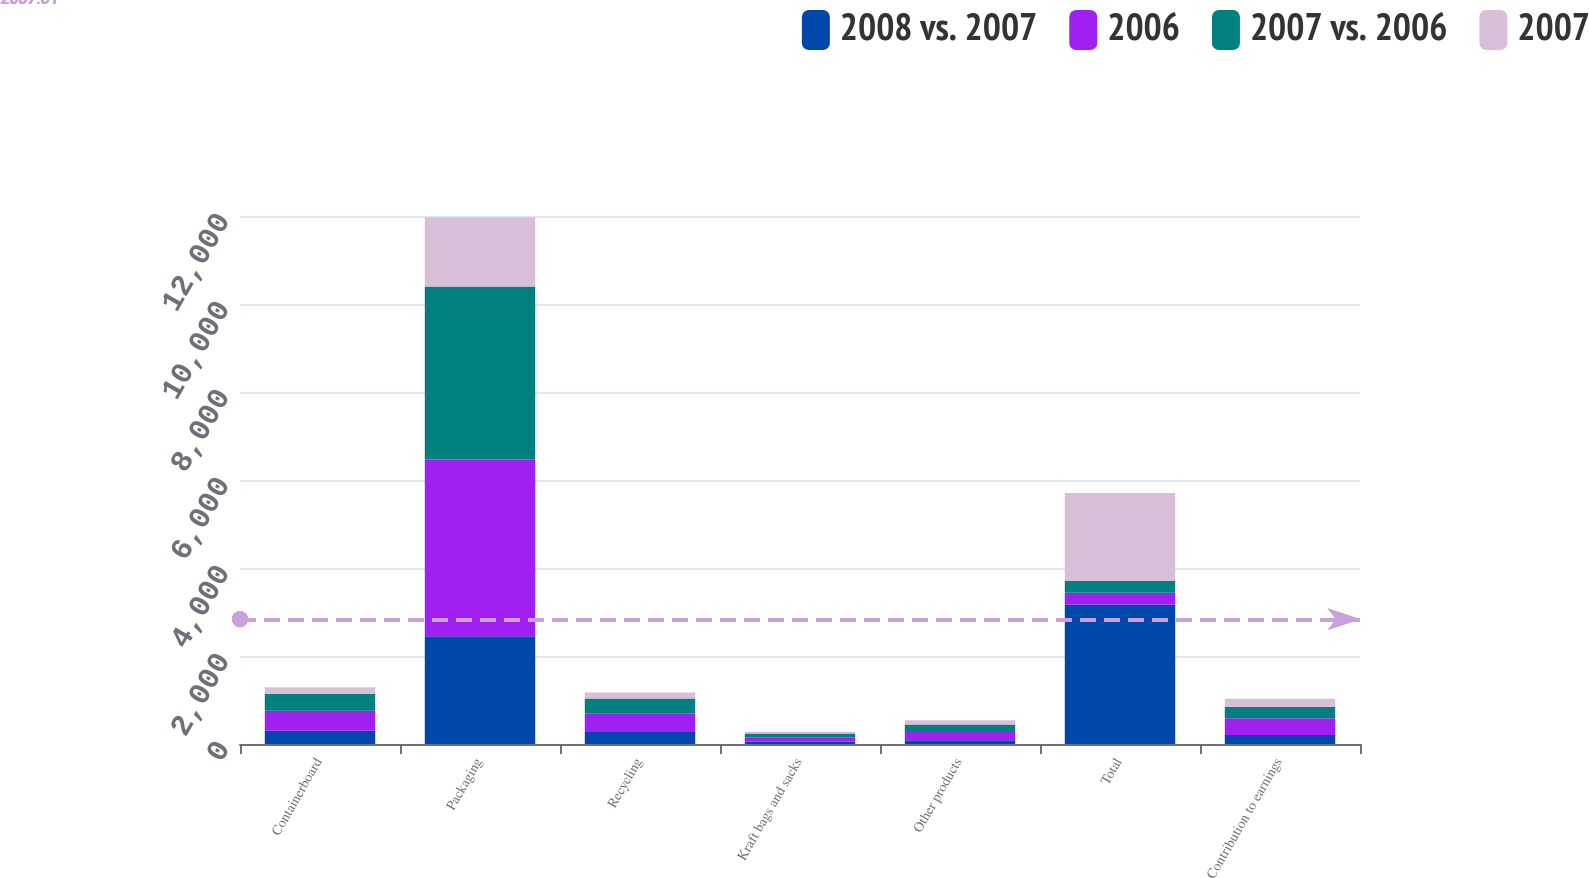Convert chart. <chart><loc_0><loc_0><loc_500><loc_500><stacked_bar_chart><ecel><fcel>Containerboard<fcel>Packaging<fcel>Recycling<fcel>Kraft bags and sacks<fcel>Other products<fcel>Total<fcel>Contribution to earnings<nl><fcel>2008 vs. 2007<fcel>301<fcel>2449<fcel>275<fcel>56<fcel>88<fcel>3169<fcel>204<nl><fcel>2006<fcel>457<fcel>4019<fcel>413<fcel>96<fcel>183<fcel>269<fcel>382<nl><fcel>2007 vs. 2006<fcel>377<fcel>3931<fcel>345<fcel>88<fcel>171<fcel>269<fcel>263<nl><fcel>2007<fcel>156<fcel>1570<fcel>138<fcel>40<fcel>95<fcel>1999<fcel>178<nl></chart> 